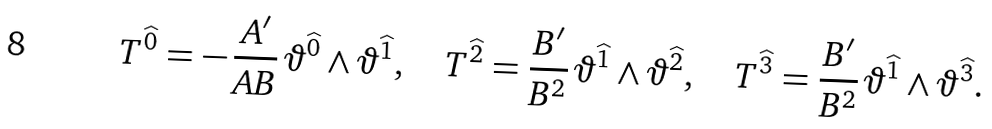<formula> <loc_0><loc_0><loc_500><loc_500>T ^ { \widehat { 0 } } = - \, { \frac { A ^ { \prime } } { A B } } \, \vartheta ^ { \widehat { 0 } } \wedge \vartheta ^ { \widehat { 1 } } , \quad T ^ { \widehat { 2 } } = { \frac { B ^ { \prime } } { B ^ { 2 } } } \, \vartheta ^ { \widehat { 1 } } \wedge \vartheta ^ { \widehat { 2 } } , \quad T ^ { \widehat { 3 } } = { \frac { B ^ { \prime } } { B ^ { 2 } } } \, \vartheta ^ { \widehat { 1 } } \wedge \vartheta ^ { \widehat { 3 } } .</formula> 